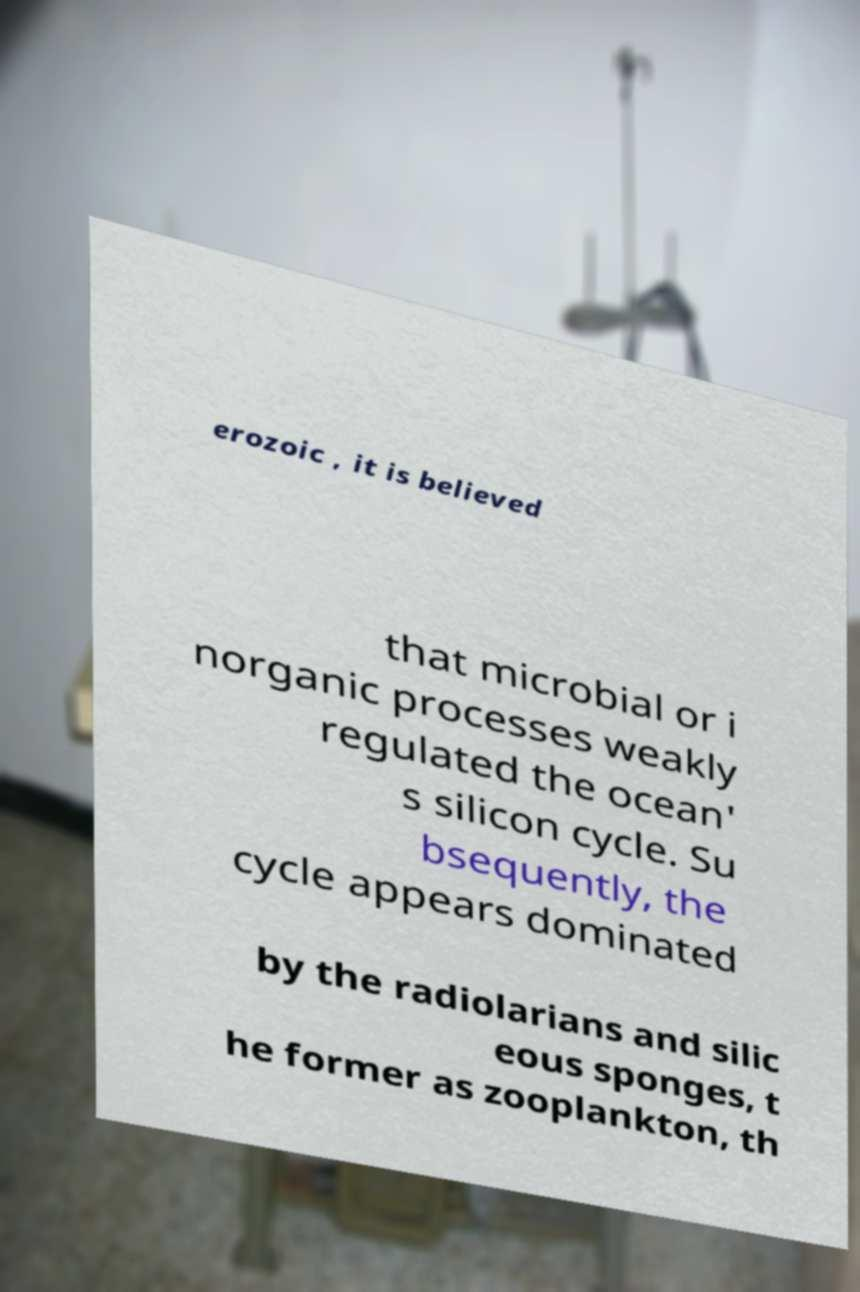Can you accurately transcribe the text from the provided image for me? erozoic , it is believed that microbial or i norganic processes weakly regulated the ocean' s silicon cycle. Su bsequently, the cycle appears dominated by the radiolarians and silic eous sponges, t he former as zooplankton, th 